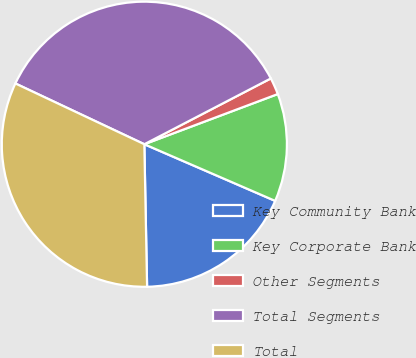Convert chart to OTSL. <chart><loc_0><loc_0><loc_500><loc_500><pie_chart><fcel>Key Community Bank<fcel>Key Corporate Bank<fcel>Other Segments<fcel>Total Segments<fcel>Total<nl><fcel>18.19%<fcel>12.23%<fcel>1.91%<fcel>35.36%<fcel>32.32%<nl></chart> 